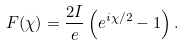Convert formula to latex. <formula><loc_0><loc_0><loc_500><loc_500>F ( \chi ) = \frac { 2 I } { e } \left ( e ^ { i \chi / 2 } - 1 \right ) .</formula> 